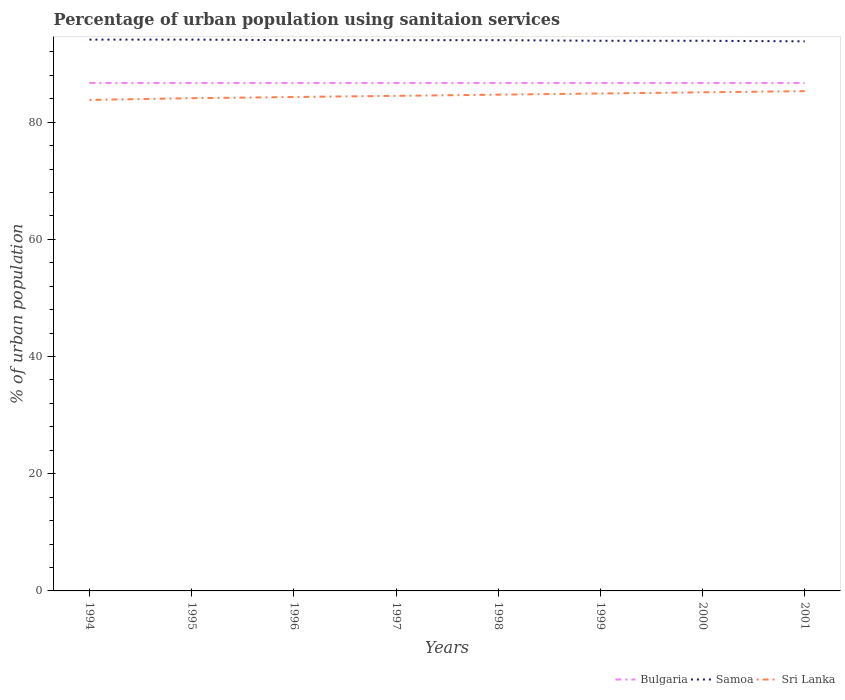How many different coloured lines are there?
Offer a very short reply. 3. Across all years, what is the maximum percentage of urban population using sanitaion services in Bulgaria?
Make the answer very short. 86.7. What is the total percentage of urban population using sanitaion services in Sri Lanka in the graph?
Ensure brevity in your answer.  -0.6. What is the difference between the highest and the second highest percentage of urban population using sanitaion services in Samoa?
Give a very brief answer. 0.3. What is the difference between the highest and the lowest percentage of urban population using sanitaion services in Samoa?
Keep it short and to the point. 5. Is the percentage of urban population using sanitaion services in Samoa strictly greater than the percentage of urban population using sanitaion services in Sri Lanka over the years?
Offer a terse response. No. Does the graph contain grids?
Offer a very short reply. No. Where does the legend appear in the graph?
Your answer should be compact. Bottom right. How many legend labels are there?
Ensure brevity in your answer.  3. What is the title of the graph?
Provide a short and direct response. Percentage of urban population using sanitaion services. What is the label or title of the X-axis?
Keep it short and to the point. Years. What is the label or title of the Y-axis?
Offer a very short reply. % of urban population. What is the % of urban population in Bulgaria in 1994?
Your response must be concise. 86.7. What is the % of urban population in Samoa in 1994?
Your answer should be compact. 94.1. What is the % of urban population in Sri Lanka in 1994?
Provide a short and direct response. 83.8. What is the % of urban population of Bulgaria in 1995?
Offer a very short reply. 86.7. What is the % of urban population of Samoa in 1995?
Provide a short and direct response. 94.1. What is the % of urban population of Sri Lanka in 1995?
Give a very brief answer. 84.1. What is the % of urban population of Bulgaria in 1996?
Provide a succinct answer. 86.7. What is the % of urban population in Samoa in 1996?
Provide a short and direct response. 94. What is the % of urban population in Sri Lanka in 1996?
Offer a terse response. 84.3. What is the % of urban population in Bulgaria in 1997?
Keep it short and to the point. 86.7. What is the % of urban population of Samoa in 1997?
Offer a very short reply. 94. What is the % of urban population in Sri Lanka in 1997?
Ensure brevity in your answer.  84.5. What is the % of urban population of Bulgaria in 1998?
Your response must be concise. 86.7. What is the % of urban population in Samoa in 1998?
Provide a succinct answer. 94. What is the % of urban population of Sri Lanka in 1998?
Your response must be concise. 84.7. What is the % of urban population in Bulgaria in 1999?
Make the answer very short. 86.7. What is the % of urban population of Samoa in 1999?
Ensure brevity in your answer.  93.9. What is the % of urban population of Sri Lanka in 1999?
Make the answer very short. 84.9. What is the % of urban population of Bulgaria in 2000?
Make the answer very short. 86.7. What is the % of urban population in Samoa in 2000?
Give a very brief answer. 93.9. What is the % of urban population of Sri Lanka in 2000?
Your answer should be compact. 85.1. What is the % of urban population of Bulgaria in 2001?
Your answer should be compact. 86.7. What is the % of urban population of Samoa in 2001?
Keep it short and to the point. 93.8. What is the % of urban population in Sri Lanka in 2001?
Your answer should be very brief. 85.3. Across all years, what is the maximum % of urban population of Bulgaria?
Make the answer very short. 86.7. Across all years, what is the maximum % of urban population in Samoa?
Your response must be concise. 94.1. Across all years, what is the maximum % of urban population of Sri Lanka?
Make the answer very short. 85.3. Across all years, what is the minimum % of urban population in Bulgaria?
Offer a very short reply. 86.7. Across all years, what is the minimum % of urban population in Samoa?
Offer a terse response. 93.8. Across all years, what is the minimum % of urban population of Sri Lanka?
Offer a terse response. 83.8. What is the total % of urban population of Bulgaria in the graph?
Offer a very short reply. 693.6. What is the total % of urban population in Samoa in the graph?
Offer a very short reply. 751.8. What is the total % of urban population in Sri Lanka in the graph?
Your answer should be very brief. 676.7. What is the difference between the % of urban population in Bulgaria in 1994 and that in 1995?
Offer a terse response. 0. What is the difference between the % of urban population of Sri Lanka in 1994 and that in 1995?
Provide a succinct answer. -0.3. What is the difference between the % of urban population of Bulgaria in 1994 and that in 1996?
Your answer should be compact. 0. What is the difference between the % of urban population in Sri Lanka in 1994 and that in 1996?
Ensure brevity in your answer.  -0.5. What is the difference between the % of urban population of Bulgaria in 1994 and that in 1997?
Give a very brief answer. 0. What is the difference between the % of urban population in Samoa in 1994 and that in 1997?
Your answer should be compact. 0.1. What is the difference between the % of urban population of Sri Lanka in 1994 and that in 1997?
Offer a very short reply. -0.7. What is the difference between the % of urban population in Sri Lanka in 1994 and that in 1998?
Offer a very short reply. -0.9. What is the difference between the % of urban population in Samoa in 1994 and that in 2001?
Make the answer very short. 0.3. What is the difference between the % of urban population in Sri Lanka in 1994 and that in 2001?
Offer a terse response. -1.5. What is the difference between the % of urban population in Samoa in 1995 and that in 1996?
Give a very brief answer. 0.1. What is the difference between the % of urban population in Sri Lanka in 1995 and that in 1996?
Provide a succinct answer. -0.2. What is the difference between the % of urban population in Bulgaria in 1995 and that in 1997?
Ensure brevity in your answer.  0. What is the difference between the % of urban population in Samoa in 1995 and that in 1997?
Your answer should be compact. 0.1. What is the difference between the % of urban population of Sri Lanka in 1995 and that in 1997?
Ensure brevity in your answer.  -0.4. What is the difference between the % of urban population in Bulgaria in 1995 and that in 1998?
Provide a short and direct response. 0. What is the difference between the % of urban population of Sri Lanka in 1995 and that in 2001?
Your answer should be very brief. -1.2. What is the difference between the % of urban population of Bulgaria in 1996 and that in 1997?
Keep it short and to the point. 0. What is the difference between the % of urban population of Sri Lanka in 1996 and that in 1997?
Offer a terse response. -0.2. What is the difference between the % of urban population in Samoa in 1996 and that in 1998?
Give a very brief answer. 0. What is the difference between the % of urban population of Sri Lanka in 1996 and that in 1999?
Make the answer very short. -0.6. What is the difference between the % of urban population of Bulgaria in 1996 and that in 2000?
Provide a short and direct response. 0. What is the difference between the % of urban population of Samoa in 1996 and that in 2000?
Your answer should be very brief. 0.1. What is the difference between the % of urban population in Samoa in 1997 and that in 1998?
Your response must be concise. 0. What is the difference between the % of urban population in Samoa in 1997 and that in 1999?
Provide a short and direct response. 0.1. What is the difference between the % of urban population in Bulgaria in 1997 and that in 2000?
Keep it short and to the point. 0. What is the difference between the % of urban population in Samoa in 1997 and that in 2000?
Ensure brevity in your answer.  0.1. What is the difference between the % of urban population in Sri Lanka in 1997 and that in 2000?
Provide a short and direct response. -0.6. What is the difference between the % of urban population in Sri Lanka in 1998 and that in 1999?
Offer a terse response. -0.2. What is the difference between the % of urban population of Bulgaria in 1998 and that in 2000?
Keep it short and to the point. 0. What is the difference between the % of urban population in Sri Lanka in 1998 and that in 2000?
Provide a short and direct response. -0.4. What is the difference between the % of urban population of Sri Lanka in 1998 and that in 2001?
Your answer should be very brief. -0.6. What is the difference between the % of urban population of Samoa in 1999 and that in 2000?
Your answer should be very brief. 0. What is the difference between the % of urban population of Sri Lanka in 1999 and that in 2000?
Ensure brevity in your answer.  -0.2. What is the difference between the % of urban population in Samoa in 1999 and that in 2001?
Your response must be concise. 0.1. What is the difference between the % of urban population of Sri Lanka in 1999 and that in 2001?
Keep it short and to the point. -0.4. What is the difference between the % of urban population of Samoa in 2000 and that in 2001?
Offer a very short reply. 0.1. What is the difference between the % of urban population of Bulgaria in 1994 and the % of urban population of Sri Lanka in 1996?
Give a very brief answer. 2.4. What is the difference between the % of urban population of Samoa in 1994 and the % of urban population of Sri Lanka in 1996?
Give a very brief answer. 9.8. What is the difference between the % of urban population in Bulgaria in 1994 and the % of urban population in Samoa in 1997?
Your answer should be compact. -7.3. What is the difference between the % of urban population in Bulgaria in 1994 and the % of urban population in Sri Lanka in 1997?
Make the answer very short. 2.2. What is the difference between the % of urban population of Samoa in 1994 and the % of urban population of Sri Lanka in 1997?
Your answer should be compact. 9.6. What is the difference between the % of urban population of Bulgaria in 1994 and the % of urban population of Sri Lanka in 1998?
Make the answer very short. 2. What is the difference between the % of urban population in Samoa in 1994 and the % of urban population in Sri Lanka in 1998?
Make the answer very short. 9.4. What is the difference between the % of urban population of Bulgaria in 1994 and the % of urban population of Sri Lanka in 1999?
Offer a terse response. 1.8. What is the difference between the % of urban population in Samoa in 1994 and the % of urban population in Sri Lanka in 1999?
Offer a very short reply. 9.2. What is the difference between the % of urban population in Bulgaria in 1994 and the % of urban population in Samoa in 2000?
Provide a short and direct response. -7.2. What is the difference between the % of urban population in Samoa in 1994 and the % of urban population in Sri Lanka in 2000?
Give a very brief answer. 9. What is the difference between the % of urban population of Bulgaria in 1994 and the % of urban population of Samoa in 2001?
Your response must be concise. -7.1. What is the difference between the % of urban population of Bulgaria in 1994 and the % of urban population of Sri Lanka in 2001?
Provide a succinct answer. 1.4. What is the difference between the % of urban population in Samoa in 1994 and the % of urban population in Sri Lanka in 2001?
Give a very brief answer. 8.8. What is the difference between the % of urban population of Bulgaria in 1995 and the % of urban population of Samoa in 1997?
Your answer should be compact. -7.3. What is the difference between the % of urban population of Bulgaria in 1995 and the % of urban population of Sri Lanka in 1997?
Your response must be concise. 2.2. What is the difference between the % of urban population of Bulgaria in 1995 and the % of urban population of Samoa in 1998?
Provide a succinct answer. -7.3. What is the difference between the % of urban population in Bulgaria in 1995 and the % of urban population in Sri Lanka in 1998?
Your answer should be very brief. 2. What is the difference between the % of urban population in Bulgaria in 1995 and the % of urban population in Samoa in 1999?
Provide a short and direct response. -7.2. What is the difference between the % of urban population of Bulgaria in 1995 and the % of urban population of Samoa in 2000?
Provide a succinct answer. -7.2. What is the difference between the % of urban population in Bulgaria in 1995 and the % of urban population in Sri Lanka in 2000?
Offer a very short reply. 1.6. What is the difference between the % of urban population of Samoa in 1995 and the % of urban population of Sri Lanka in 2000?
Make the answer very short. 9. What is the difference between the % of urban population of Bulgaria in 1995 and the % of urban population of Samoa in 2001?
Give a very brief answer. -7.1. What is the difference between the % of urban population of Bulgaria in 1995 and the % of urban population of Sri Lanka in 2001?
Provide a succinct answer. 1.4. What is the difference between the % of urban population in Bulgaria in 1996 and the % of urban population in Sri Lanka in 1997?
Your answer should be compact. 2.2. What is the difference between the % of urban population of Samoa in 1996 and the % of urban population of Sri Lanka in 1998?
Your answer should be very brief. 9.3. What is the difference between the % of urban population of Bulgaria in 1996 and the % of urban population of Samoa in 1999?
Keep it short and to the point. -7.2. What is the difference between the % of urban population of Bulgaria in 1996 and the % of urban population of Sri Lanka in 1999?
Your answer should be very brief. 1.8. What is the difference between the % of urban population in Bulgaria in 1996 and the % of urban population in Sri Lanka in 2000?
Keep it short and to the point. 1.6. What is the difference between the % of urban population in Bulgaria in 1996 and the % of urban population in Samoa in 2001?
Provide a succinct answer. -7.1. What is the difference between the % of urban population of Bulgaria in 1996 and the % of urban population of Sri Lanka in 2001?
Ensure brevity in your answer.  1.4. What is the difference between the % of urban population in Samoa in 1996 and the % of urban population in Sri Lanka in 2001?
Your answer should be compact. 8.7. What is the difference between the % of urban population in Bulgaria in 1997 and the % of urban population in Samoa in 1999?
Ensure brevity in your answer.  -7.2. What is the difference between the % of urban population of Samoa in 1997 and the % of urban population of Sri Lanka in 1999?
Your answer should be very brief. 9.1. What is the difference between the % of urban population of Bulgaria in 1997 and the % of urban population of Samoa in 2000?
Offer a very short reply. -7.2. What is the difference between the % of urban population in Samoa in 1997 and the % of urban population in Sri Lanka in 2000?
Offer a very short reply. 8.9. What is the difference between the % of urban population of Samoa in 1997 and the % of urban population of Sri Lanka in 2001?
Offer a very short reply. 8.7. What is the difference between the % of urban population in Bulgaria in 1998 and the % of urban population in Samoa in 1999?
Your response must be concise. -7.2. What is the difference between the % of urban population of Samoa in 1998 and the % of urban population of Sri Lanka in 1999?
Ensure brevity in your answer.  9.1. What is the difference between the % of urban population in Bulgaria in 1998 and the % of urban population in Sri Lanka in 2000?
Offer a very short reply. 1.6. What is the difference between the % of urban population in Bulgaria in 1998 and the % of urban population in Sri Lanka in 2001?
Provide a short and direct response. 1.4. What is the difference between the % of urban population in Bulgaria in 1999 and the % of urban population in Sri Lanka in 2000?
Make the answer very short. 1.6. What is the difference between the % of urban population of Samoa in 1999 and the % of urban population of Sri Lanka in 2001?
Provide a short and direct response. 8.6. What is the difference between the % of urban population of Bulgaria in 2000 and the % of urban population of Samoa in 2001?
Make the answer very short. -7.1. What is the difference between the % of urban population in Samoa in 2000 and the % of urban population in Sri Lanka in 2001?
Offer a very short reply. 8.6. What is the average % of urban population of Bulgaria per year?
Make the answer very short. 86.7. What is the average % of urban population of Samoa per year?
Your answer should be very brief. 93.97. What is the average % of urban population of Sri Lanka per year?
Make the answer very short. 84.59. In the year 1995, what is the difference between the % of urban population in Bulgaria and % of urban population in Samoa?
Your response must be concise. -7.4. In the year 1996, what is the difference between the % of urban population in Bulgaria and % of urban population in Samoa?
Your answer should be very brief. -7.3. In the year 1996, what is the difference between the % of urban population in Bulgaria and % of urban population in Sri Lanka?
Offer a very short reply. 2.4. In the year 1997, what is the difference between the % of urban population in Bulgaria and % of urban population in Samoa?
Your answer should be very brief. -7.3. In the year 1997, what is the difference between the % of urban population in Bulgaria and % of urban population in Sri Lanka?
Ensure brevity in your answer.  2.2. In the year 1997, what is the difference between the % of urban population in Samoa and % of urban population in Sri Lanka?
Keep it short and to the point. 9.5. In the year 1998, what is the difference between the % of urban population of Samoa and % of urban population of Sri Lanka?
Keep it short and to the point. 9.3. In the year 1999, what is the difference between the % of urban population of Bulgaria and % of urban population of Samoa?
Provide a succinct answer. -7.2. In the year 1999, what is the difference between the % of urban population of Samoa and % of urban population of Sri Lanka?
Your answer should be very brief. 9. In the year 2000, what is the difference between the % of urban population in Bulgaria and % of urban population in Sri Lanka?
Offer a very short reply. 1.6. In the year 2001, what is the difference between the % of urban population in Bulgaria and % of urban population in Samoa?
Your response must be concise. -7.1. In the year 2001, what is the difference between the % of urban population in Samoa and % of urban population in Sri Lanka?
Ensure brevity in your answer.  8.5. What is the ratio of the % of urban population of Bulgaria in 1994 to that in 1995?
Provide a succinct answer. 1. What is the ratio of the % of urban population of Sri Lanka in 1994 to that in 1995?
Make the answer very short. 1. What is the ratio of the % of urban population of Sri Lanka in 1994 to that in 1996?
Provide a succinct answer. 0.99. What is the ratio of the % of urban population in Samoa in 1994 to that in 1997?
Your answer should be compact. 1. What is the ratio of the % of urban population of Samoa in 1994 to that in 1998?
Provide a succinct answer. 1. What is the ratio of the % of urban population of Bulgaria in 1994 to that in 1999?
Your response must be concise. 1. What is the ratio of the % of urban population of Samoa in 1994 to that in 1999?
Make the answer very short. 1. What is the ratio of the % of urban population in Samoa in 1994 to that in 2000?
Offer a terse response. 1. What is the ratio of the % of urban population of Sri Lanka in 1994 to that in 2000?
Ensure brevity in your answer.  0.98. What is the ratio of the % of urban population in Bulgaria in 1994 to that in 2001?
Provide a short and direct response. 1. What is the ratio of the % of urban population in Sri Lanka in 1994 to that in 2001?
Keep it short and to the point. 0.98. What is the ratio of the % of urban population in Bulgaria in 1995 to that in 1996?
Offer a very short reply. 1. What is the ratio of the % of urban population of Samoa in 1995 to that in 1998?
Offer a very short reply. 1. What is the ratio of the % of urban population in Sri Lanka in 1995 to that in 1999?
Give a very brief answer. 0.99. What is the ratio of the % of urban population of Sri Lanka in 1995 to that in 2000?
Provide a succinct answer. 0.99. What is the ratio of the % of urban population of Bulgaria in 1995 to that in 2001?
Provide a succinct answer. 1. What is the ratio of the % of urban population in Samoa in 1995 to that in 2001?
Give a very brief answer. 1. What is the ratio of the % of urban population of Sri Lanka in 1995 to that in 2001?
Offer a terse response. 0.99. What is the ratio of the % of urban population of Bulgaria in 1996 to that in 1997?
Provide a succinct answer. 1. What is the ratio of the % of urban population in Sri Lanka in 1996 to that in 1997?
Your answer should be very brief. 1. What is the ratio of the % of urban population in Samoa in 1996 to that in 1998?
Make the answer very short. 1. What is the ratio of the % of urban population in Sri Lanka in 1996 to that in 2000?
Offer a very short reply. 0.99. What is the ratio of the % of urban population in Bulgaria in 1996 to that in 2001?
Make the answer very short. 1. What is the ratio of the % of urban population of Sri Lanka in 1996 to that in 2001?
Your answer should be very brief. 0.99. What is the ratio of the % of urban population in Samoa in 1997 to that in 1998?
Your response must be concise. 1. What is the ratio of the % of urban population of Samoa in 1997 to that in 1999?
Your answer should be very brief. 1. What is the ratio of the % of urban population of Samoa in 1997 to that in 2000?
Give a very brief answer. 1. What is the ratio of the % of urban population in Sri Lanka in 1997 to that in 2001?
Provide a succinct answer. 0.99. What is the ratio of the % of urban population of Sri Lanka in 1998 to that in 1999?
Offer a very short reply. 1. What is the ratio of the % of urban population in Bulgaria in 1998 to that in 2000?
Make the answer very short. 1. What is the ratio of the % of urban population of Samoa in 1998 to that in 2000?
Offer a very short reply. 1. What is the ratio of the % of urban population of Samoa in 1998 to that in 2001?
Your response must be concise. 1. What is the ratio of the % of urban population of Sri Lanka in 1998 to that in 2001?
Provide a short and direct response. 0.99. What is the ratio of the % of urban population in Bulgaria in 1999 to that in 2000?
Your response must be concise. 1. What is the ratio of the % of urban population in Samoa in 1999 to that in 2000?
Keep it short and to the point. 1. What is the ratio of the % of urban population in Bulgaria in 1999 to that in 2001?
Make the answer very short. 1. What is the difference between the highest and the second highest % of urban population of Bulgaria?
Provide a short and direct response. 0. What is the difference between the highest and the second highest % of urban population in Samoa?
Your answer should be compact. 0. What is the difference between the highest and the lowest % of urban population of Bulgaria?
Give a very brief answer. 0. What is the difference between the highest and the lowest % of urban population of Samoa?
Your answer should be very brief. 0.3. 